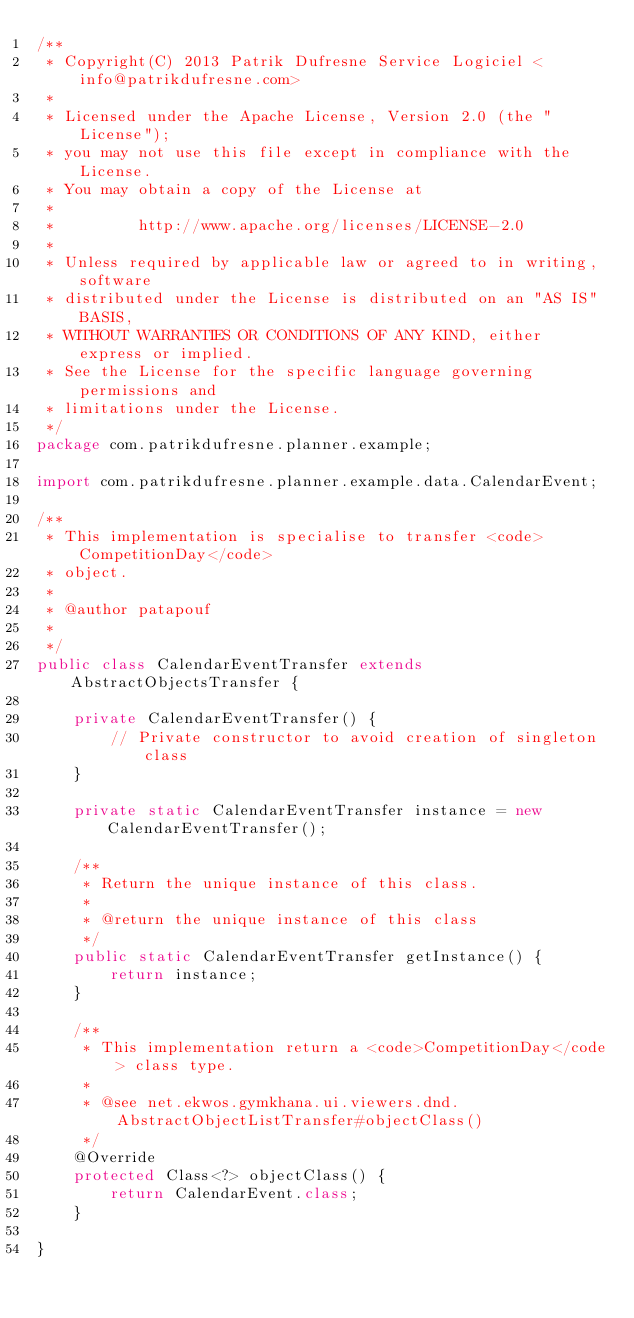Convert code to text. <code><loc_0><loc_0><loc_500><loc_500><_Java_>/**
 * Copyright(C) 2013 Patrik Dufresne Service Logiciel <info@patrikdufresne.com>
 *
 * Licensed under the Apache License, Version 2.0 (the "License");
 * you may not use this file except in compliance with the License.
 * You may obtain a copy of the License at
 *
 *         http://www.apache.org/licenses/LICENSE-2.0
 *
 * Unless required by applicable law or agreed to in writing, software
 * distributed under the License is distributed on an "AS IS" BASIS,
 * WITHOUT WARRANTIES OR CONDITIONS OF ANY KIND, either express or implied.
 * See the License for the specific language governing permissions and
 * limitations under the License.
 */
package com.patrikdufresne.planner.example;

import com.patrikdufresne.planner.example.data.CalendarEvent;

/**
 * This implementation is specialise to transfer <code>CompetitionDay</code>
 * object.
 * 
 * @author patapouf
 * 
 */
public class CalendarEventTransfer extends AbstractObjectsTransfer {

    private CalendarEventTransfer() {
        // Private constructor to avoid creation of singleton class
    }

    private static CalendarEventTransfer instance = new CalendarEventTransfer();

    /**
     * Return the unique instance of this class.
     * 
     * @return the unique instance of this class
     */
    public static CalendarEventTransfer getInstance() {
        return instance;
    }

    /**
     * This implementation return a <code>CompetitionDay</code> class type.
     * 
     * @see net.ekwos.gymkhana.ui.viewers.dnd.AbstractObjectListTransfer#objectClass()
     */
    @Override
    protected Class<?> objectClass() {
        return CalendarEvent.class;
    }

}</code> 